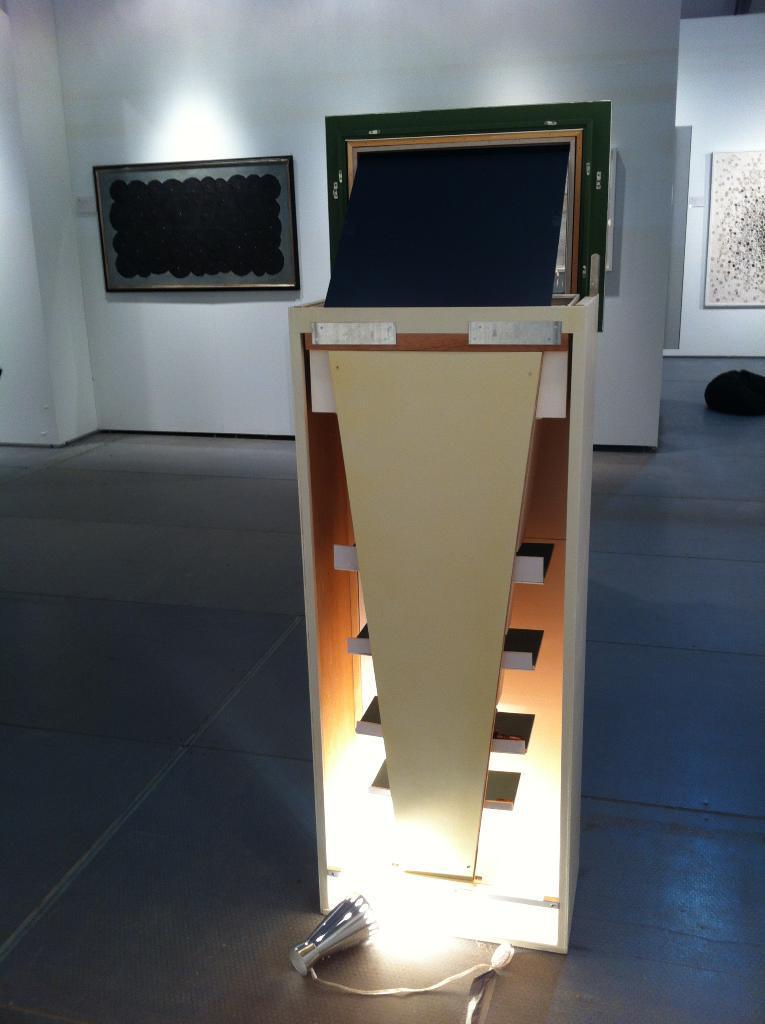How would you summarize this image in a sentence or two? There is a stand. Near to the stand there is a light on the floor. In the background there is a wall with a photo frame. 